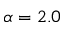<formula> <loc_0><loc_0><loc_500><loc_500>\alpha = 2 . 0</formula> 